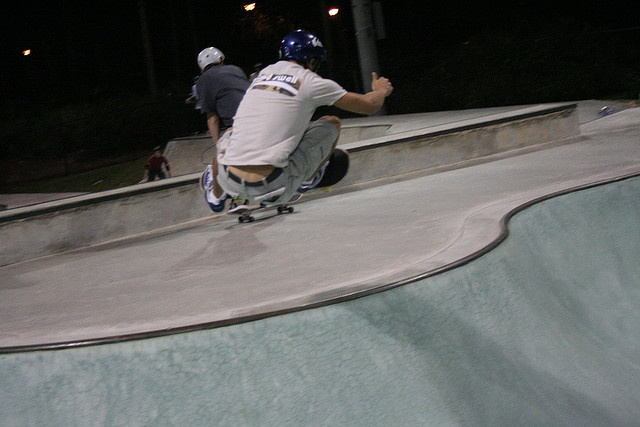<image>Is this place specifically for skateboarding? I am not sure if this place is specifically for skateboarding. Is this place specifically for skateboarding? I don't know if this place is specifically for skateboarding. It can be both for skateboarding and not for skateboarding. 